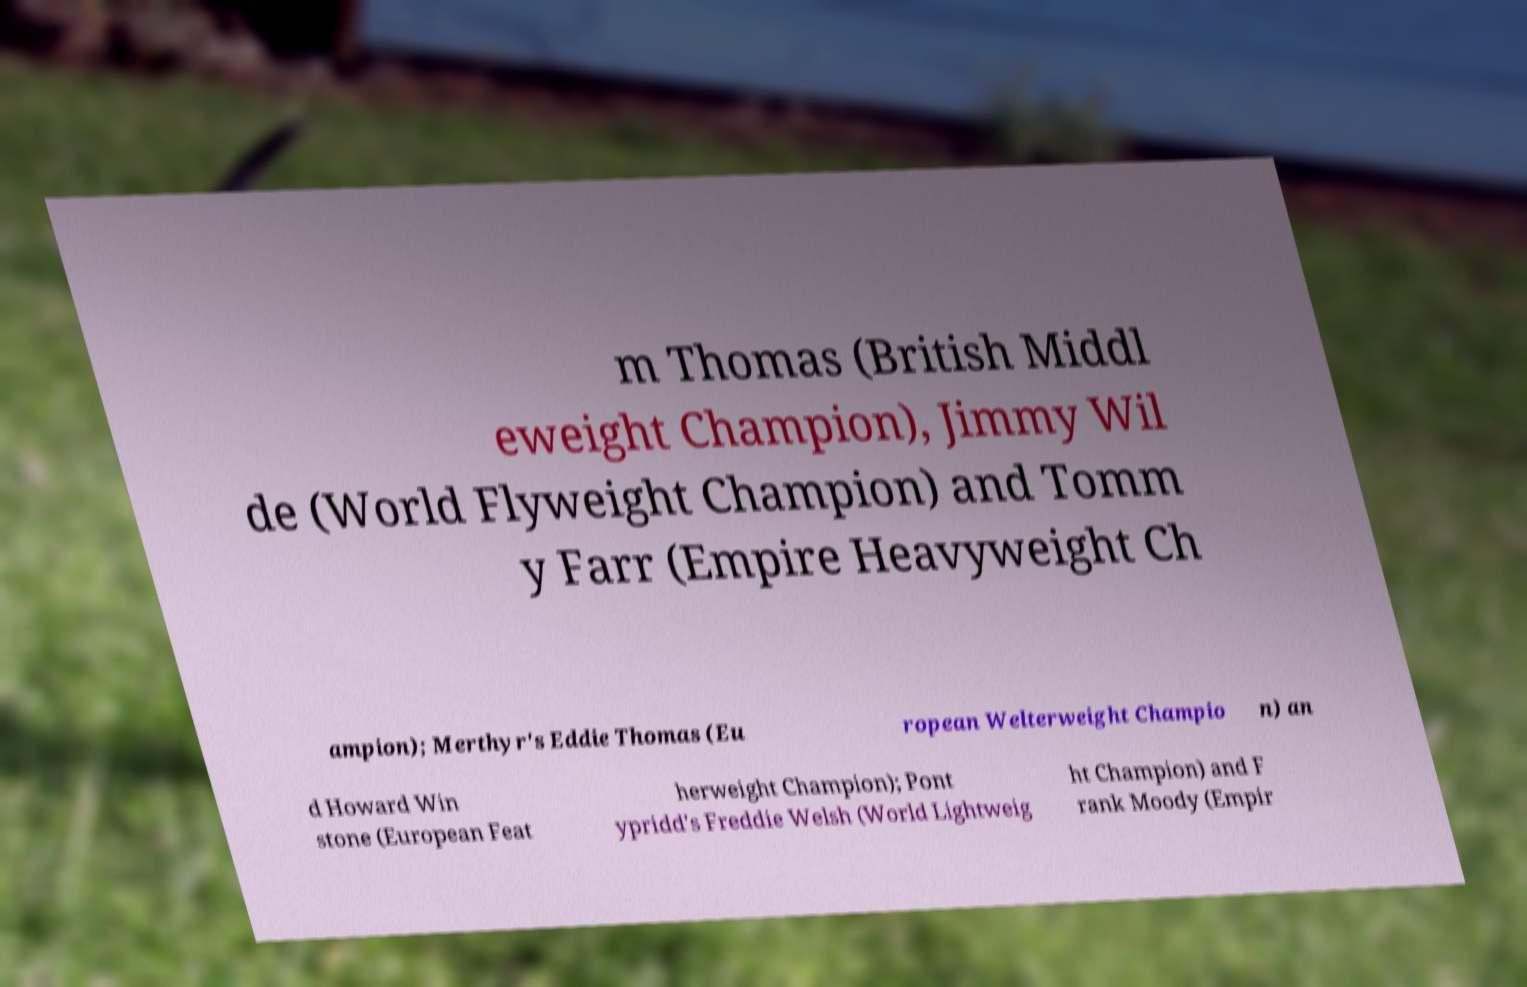Please read and relay the text visible in this image. What does it say? m Thomas (British Middl eweight Champion), Jimmy Wil de (World Flyweight Champion) and Tomm y Farr (Empire Heavyweight Ch ampion); Merthyr's Eddie Thomas (Eu ropean Welterweight Champio n) an d Howard Win stone (European Feat herweight Champion); Pont ypridd's Freddie Welsh (World Lightweig ht Champion) and F rank Moody (Empir 